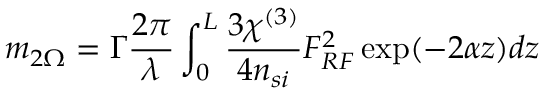Convert formula to latex. <formula><loc_0><loc_0><loc_500><loc_500>m _ { 2 \Omega } = \Gamma \frac { 2 \pi } { \lambda } \int _ { 0 } ^ { L } \frac { 3 \chi ^ { ( 3 ) } } { 4 n _ { s i } } F _ { R F } ^ { 2 } \exp ( - 2 \alpha z ) d z</formula> 